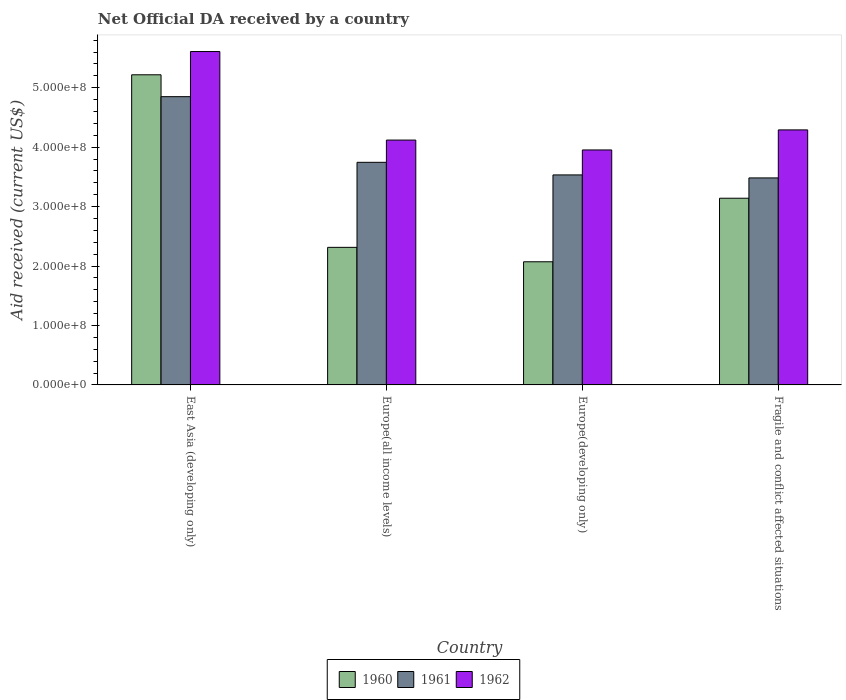How many different coloured bars are there?
Your response must be concise. 3. How many groups of bars are there?
Your answer should be compact. 4. Are the number of bars per tick equal to the number of legend labels?
Your response must be concise. Yes. How many bars are there on the 3rd tick from the right?
Make the answer very short. 3. What is the label of the 3rd group of bars from the left?
Ensure brevity in your answer.  Europe(developing only). What is the net official development assistance aid received in 1960 in Europe(all income levels)?
Make the answer very short. 2.31e+08. Across all countries, what is the maximum net official development assistance aid received in 1960?
Your response must be concise. 5.22e+08. Across all countries, what is the minimum net official development assistance aid received in 1962?
Your response must be concise. 3.95e+08. In which country was the net official development assistance aid received in 1960 maximum?
Your response must be concise. East Asia (developing only). In which country was the net official development assistance aid received in 1961 minimum?
Give a very brief answer. Fragile and conflict affected situations. What is the total net official development assistance aid received in 1960 in the graph?
Your answer should be compact. 1.27e+09. What is the difference between the net official development assistance aid received in 1960 in Europe(all income levels) and that in Fragile and conflict affected situations?
Give a very brief answer. -8.27e+07. What is the difference between the net official development assistance aid received in 1960 in Fragile and conflict affected situations and the net official development assistance aid received in 1961 in Europe(developing only)?
Ensure brevity in your answer.  -3.92e+07. What is the average net official development assistance aid received in 1960 per country?
Offer a terse response. 3.19e+08. What is the difference between the net official development assistance aid received of/in 1962 and net official development assistance aid received of/in 1961 in East Asia (developing only)?
Give a very brief answer. 7.59e+07. In how many countries, is the net official development assistance aid received in 1960 greater than 240000000 US$?
Your answer should be very brief. 2. What is the ratio of the net official development assistance aid received in 1961 in Europe(all income levels) to that in Fragile and conflict affected situations?
Your response must be concise. 1.08. Is the net official development assistance aid received in 1960 in Europe(all income levels) less than that in Fragile and conflict affected situations?
Your response must be concise. Yes. What is the difference between the highest and the second highest net official development assistance aid received in 1962?
Offer a terse response. 1.32e+08. What is the difference between the highest and the lowest net official development assistance aid received in 1962?
Give a very brief answer. 1.66e+08. In how many countries, is the net official development assistance aid received in 1961 greater than the average net official development assistance aid received in 1961 taken over all countries?
Your answer should be very brief. 1. Is the sum of the net official development assistance aid received in 1962 in East Asia (developing only) and Fragile and conflict affected situations greater than the maximum net official development assistance aid received in 1960 across all countries?
Offer a very short reply. Yes. What does the 1st bar from the left in Europe(all income levels) represents?
Give a very brief answer. 1960. Is it the case that in every country, the sum of the net official development assistance aid received in 1961 and net official development assistance aid received in 1960 is greater than the net official development assistance aid received in 1962?
Offer a terse response. Yes. How many bars are there?
Keep it short and to the point. 12. Are all the bars in the graph horizontal?
Your answer should be compact. No. Are the values on the major ticks of Y-axis written in scientific E-notation?
Give a very brief answer. Yes. Does the graph contain any zero values?
Provide a short and direct response. No. Where does the legend appear in the graph?
Your answer should be very brief. Bottom center. What is the title of the graph?
Your answer should be compact. Net Official DA received by a country. What is the label or title of the X-axis?
Your answer should be compact. Country. What is the label or title of the Y-axis?
Offer a terse response. Aid received (current US$). What is the Aid received (current US$) in 1960 in East Asia (developing only)?
Your answer should be very brief. 5.22e+08. What is the Aid received (current US$) in 1961 in East Asia (developing only)?
Your response must be concise. 4.85e+08. What is the Aid received (current US$) of 1962 in East Asia (developing only)?
Your response must be concise. 5.61e+08. What is the Aid received (current US$) of 1960 in Europe(all income levels)?
Ensure brevity in your answer.  2.31e+08. What is the Aid received (current US$) of 1961 in Europe(all income levels)?
Keep it short and to the point. 3.75e+08. What is the Aid received (current US$) of 1962 in Europe(all income levels)?
Offer a very short reply. 4.12e+08. What is the Aid received (current US$) of 1960 in Europe(developing only)?
Provide a short and direct response. 2.07e+08. What is the Aid received (current US$) in 1961 in Europe(developing only)?
Make the answer very short. 3.53e+08. What is the Aid received (current US$) of 1962 in Europe(developing only)?
Give a very brief answer. 3.95e+08. What is the Aid received (current US$) in 1960 in Fragile and conflict affected situations?
Your response must be concise. 3.14e+08. What is the Aid received (current US$) of 1961 in Fragile and conflict affected situations?
Give a very brief answer. 3.48e+08. What is the Aid received (current US$) in 1962 in Fragile and conflict affected situations?
Keep it short and to the point. 4.29e+08. Across all countries, what is the maximum Aid received (current US$) of 1960?
Provide a short and direct response. 5.22e+08. Across all countries, what is the maximum Aid received (current US$) in 1961?
Offer a very short reply. 4.85e+08. Across all countries, what is the maximum Aid received (current US$) in 1962?
Keep it short and to the point. 5.61e+08. Across all countries, what is the minimum Aid received (current US$) in 1960?
Keep it short and to the point. 2.07e+08. Across all countries, what is the minimum Aid received (current US$) of 1961?
Give a very brief answer. 3.48e+08. Across all countries, what is the minimum Aid received (current US$) in 1962?
Make the answer very short. 3.95e+08. What is the total Aid received (current US$) of 1960 in the graph?
Make the answer very short. 1.27e+09. What is the total Aid received (current US$) of 1961 in the graph?
Offer a very short reply. 1.56e+09. What is the total Aid received (current US$) in 1962 in the graph?
Offer a terse response. 1.80e+09. What is the difference between the Aid received (current US$) of 1960 in East Asia (developing only) and that in Europe(all income levels)?
Your response must be concise. 2.90e+08. What is the difference between the Aid received (current US$) of 1961 in East Asia (developing only) and that in Europe(all income levels)?
Ensure brevity in your answer.  1.10e+08. What is the difference between the Aid received (current US$) of 1962 in East Asia (developing only) and that in Europe(all income levels)?
Give a very brief answer. 1.49e+08. What is the difference between the Aid received (current US$) in 1960 in East Asia (developing only) and that in Europe(developing only)?
Offer a terse response. 3.15e+08. What is the difference between the Aid received (current US$) in 1961 in East Asia (developing only) and that in Europe(developing only)?
Your answer should be very brief. 1.32e+08. What is the difference between the Aid received (current US$) in 1962 in East Asia (developing only) and that in Europe(developing only)?
Your response must be concise. 1.66e+08. What is the difference between the Aid received (current US$) of 1960 in East Asia (developing only) and that in Fragile and conflict affected situations?
Ensure brevity in your answer.  2.08e+08. What is the difference between the Aid received (current US$) of 1961 in East Asia (developing only) and that in Fragile and conflict affected situations?
Provide a short and direct response. 1.37e+08. What is the difference between the Aid received (current US$) in 1962 in East Asia (developing only) and that in Fragile and conflict affected situations?
Make the answer very short. 1.32e+08. What is the difference between the Aid received (current US$) of 1960 in Europe(all income levels) and that in Europe(developing only)?
Give a very brief answer. 2.43e+07. What is the difference between the Aid received (current US$) in 1961 in Europe(all income levels) and that in Europe(developing only)?
Your answer should be compact. 2.12e+07. What is the difference between the Aid received (current US$) of 1962 in Europe(all income levels) and that in Europe(developing only)?
Offer a very short reply. 1.66e+07. What is the difference between the Aid received (current US$) of 1960 in Europe(all income levels) and that in Fragile and conflict affected situations?
Your answer should be compact. -8.27e+07. What is the difference between the Aid received (current US$) of 1961 in Europe(all income levels) and that in Fragile and conflict affected situations?
Your answer should be compact. 2.62e+07. What is the difference between the Aid received (current US$) of 1962 in Europe(all income levels) and that in Fragile and conflict affected situations?
Keep it short and to the point. -1.71e+07. What is the difference between the Aid received (current US$) in 1960 in Europe(developing only) and that in Fragile and conflict affected situations?
Provide a succinct answer. -1.07e+08. What is the difference between the Aid received (current US$) in 1961 in Europe(developing only) and that in Fragile and conflict affected situations?
Ensure brevity in your answer.  5.04e+06. What is the difference between the Aid received (current US$) in 1962 in Europe(developing only) and that in Fragile and conflict affected situations?
Your answer should be compact. -3.38e+07. What is the difference between the Aid received (current US$) in 1960 in East Asia (developing only) and the Aid received (current US$) in 1961 in Europe(all income levels)?
Provide a short and direct response. 1.47e+08. What is the difference between the Aid received (current US$) of 1960 in East Asia (developing only) and the Aid received (current US$) of 1962 in Europe(all income levels)?
Your answer should be compact. 1.10e+08. What is the difference between the Aid received (current US$) in 1961 in East Asia (developing only) and the Aid received (current US$) in 1962 in Europe(all income levels)?
Give a very brief answer. 7.30e+07. What is the difference between the Aid received (current US$) in 1960 in East Asia (developing only) and the Aid received (current US$) in 1961 in Europe(developing only)?
Offer a terse response. 1.68e+08. What is the difference between the Aid received (current US$) in 1960 in East Asia (developing only) and the Aid received (current US$) in 1962 in Europe(developing only)?
Keep it short and to the point. 1.26e+08. What is the difference between the Aid received (current US$) in 1961 in East Asia (developing only) and the Aid received (current US$) in 1962 in Europe(developing only)?
Your response must be concise. 8.97e+07. What is the difference between the Aid received (current US$) in 1960 in East Asia (developing only) and the Aid received (current US$) in 1961 in Fragile and conflict affected situations?
Give a very brief answer. 1.74e+08. What is the difference between the Aid received (current US$) in 1960 in East Asia (developing only) and the Aid received (current US$) in 1962 in Fragile and conflict affected situations?
Offer a terse response. 9.27e+07. What is the difference between the Aid received (current US$) of 1961 in East Asia (developing only) and the Aid received (current US$) of 1962 in Fragile and conflict affected situations?
Offer a very short reply. 5.59e+07. What is the difference between the Aid received (current US$) of 1960 in Europe(all income levels) and the Aid received (current US$) of 1961 in Europe(developing only)?
Make the answer very short. -1.22e+08. What is the difference between the Aid received (current US$) in 1960 in Europe(all income levels) and the Aid received (current US$) in 1962 in Europe(developing only)?
Your response must be concise. -1.64e+08. What is the difference between the Aid received (current US$) of 1961 in Europe(all income levels) and the Aid received (current US$) of 1962 in Europe(developing only)?
Your answer should be compact. -2.08e+07. What is the difference between the Aid received (current US$) in 1960 in Europe(all income levels) and the Aid received (current US$) in 1961 in Fragile and conflict affected situations?
Give a very brief answer. -1.17e+08. What is the difference between the Aid received (current US$) in 1960 in Europe(all income levels) and the Aid received (current US$) in 1962 in Fragile and conflict affected situations?
Offer a very short reply. -1.98e+08. What is the difference between the Aid received (current US$) in 1961 in Europe(all income levels) and the Aid received (current US$) in 1962 in Fragile and conflict affected situations?
Give a very brief answer. -5.46e+07. What is the difference between the Aid received (current US$) in 1960 in Europe(developing only) and the Aid received (current US$) in 1961 in Fragile and conflict affected situations?
Make the answer very short. -1.41e+08. What is the difference between the Aid received (current US$) in 1960 in Europe(developing only) and the Aid received (current US$) in 1962 in Fragile and conflict affected situations?
Your answer should be very brief. -2.22e+08. What is the difference between the Aid received (current US$) in 1961 in Europe(developing only) and the Aid received (current US$) in 1962 in Fragile and conflict affected situations?
Ensure brevity in your answer.  -7.58e+07. What is the average Aid received (current US$) of 1960 per country?
Your response must be concise. 3.19e+08. What is the average Aid received (current US$) of 1961 per country?
Your answer should be compact. 3.90e+08. What is the average Aid received (current US$) of 1962 per country?
Ensure brevity in your answer.  4.49e+08. What is the difference between the Aid received (current US$) of 1960 and Aid received (current US$) of 1961 in East Asia (developing only)?
Your answer should be compact. 3.68e+07. What is the difference between the Aid received (current US$) of 1960 and Aid received (current US$) of 1962 in East Asia (developing only)?
Your answer should be compact. -3.91e+07. What is the difference between the Aid received (current US$) in 1961 and Aid received (current US$) in 1962 in East Asia (developing only)?
Ensure brevity in your answer.  -7.59e+07. What is the difference between the Aid received (current US$) of 1960 and Aid received (current US$) of 1961 in Europe(all income levels)?
Keep it short and to the point. -1.43e+08. What is the difference between the Aid received (current US$) in 1960 and Aid received (current US$) in 1962 in Europe(all income levels)?
Keep it short and to the point. -1.81e+08. What is the difference between the Aid received (current US$) in 1961 and Aid received (current US$) in 1962 in Europe(all income levels)?
Your answer should be compact. -3.74e+07. What is the difference between the Aid received (current US$) in 1960 and Aid received (current US$) in 1961 in Europe(developing only)?
Provide a short and direct response. -1.46e+08. What is the difference between the Aid received (current US$) in 1960 and Aid received (current US$) in 1962 in Europe(developing only)?
Make the answer very short. -1.88e+08. What is the difference between the Aid received (current US$) of 1961 and Aid received (current US$) of 1962 in Europe(developing only)?
Keep it short and to the point. -4.20e+07. What is the difference between the Aid received (current US$) in 1960 and Aid received (current US$) in 1961 in Fragile and conflict affected situations?
Offer a very short reply. -3.42e+07. What is the difference between the Aid received (current US$) in 1960 and Aid received (current US$) in 1962 in Fragile and conflict affected situations?
Provide a short and direct response. -1.15e+08. What is the difference between the Aid received (current US$) in 1961 and Aid received (current US$) in 1962 in Fragile and conflict affected situations?
Offer a very short reply. -8.08e+07. What is the ratio of the Aid received (current US$) in 1960 in East Asia (developing only) to that in Europe(all income levels)?
Make the answer very short. 2.25. What is the ratio of the Aid received (current US$) in 1961 in East Asia (developing only) to that in Europe(all income levels)?
Offer a very short reply. 1.29. What is the ratio of the Aid received (current US$) of 1962 in East Asia (developing only) to that in Europe(all income levels)?
Offer a terse response. 1.36. What is the ratio of the Aid received (current US$) in 1960 in East Asia (developing only) to that in Europe(developing only)?
Provide a short and direct response. 2.52. What is the ratio of the Aid received (current US$) of 1961 in East Asia (developing only) to that in Europe(developing only)?
Your answer should be very brief. 1.37. What is the ratio of the Aid received (current US$) in 1962 in East Asia (developing only) to that in Europe(developing only)?
Give a very brief answer. 1.42. What is the ratio of the Aid received (current US$) in 1960 in East Asia (developing only) to that in Fragile and conflict affected situations?
Offer a very short reply. 1.66. What is the ratio of the Aid received (current US$) in 1961 in East Asia (developing only) to that in Fragile and conflict affected situations?
Your answer should be very brief. 1.39. What is the ratio of the Aid received (current US$) of 1962 in East Asia (developing only) to that in Fragile and conflict affected situations?
Your answer should be compact. 1.31. What is the ratio of the Aid received (current US$) in 1960 in Europe(all income levels) to that in Europe(developing only)?
Your answer should be very brief. 1.12. What is the ratio of the Aid received (current US$) in 1961 in Europe(all income levels) to that in Europe(developing only)?
Ensure brevity in your answer.  1.06. What is the ratio of the Aid received (current US$) in 1962 in Europe(all income levels) to that in Europe(developing only)?
Offer a very short reply. 1.04. What is the ratio of the Aid received (current US$) in 1960 in Europe(all income levels) to that in Fragile and conflict affected situations?
Ensure brevity in your answer.  0.74. What is the ratio of the Aid received (current US$) of 1961 in Europe(all income levels) to that in Fragile and conflict affected situations?
Your answer should be very brief. 1.08. What is the ratio of the Aid received (current US$) in 1962 in Europe(all income levels) to that in Fragile and conflict affected situations?
Your response must be concise. 0.96. What is the ratio of the Aid received (current US$) of 1960 in Europe(developing only) to that in Fragile and conflict affected situations?
Provide a short and direct response. 0.66. What is the ratio of the Aid received (current US$) of 1961 in Europe(developing only) to that in Fragile and conflict affected situations?
Your answer should be very brief. 1.01. What is the ratio of the Aid received (current US$) of 1962 in Europe(developing only) to that in Fragile and conflict affected situations?
Your response must be concise. 0.92. What is the difference between the highest and the second highest Aid received (current US$) of 1960?
Provide a short and direct response. 2.08e+08. What is the difference between the highest and the second highest Aid received (current US$) in 1961?
Keep it short and to the point. 1.10e+08. What is the difference between the highest and the second highest Aid received (current US$) of 1962?
Your answer should be very brief. 1.32e+08. What is the difference between the highest and the lowest Aid received (current US$) in 1960?
Provide a short and direct response. 3.15e+08. What is the difference between the highest and the lowest Aid received (current US$) of 1961?
Offer a terse response. 1.37e+08. What is the difference between the highest and the lowest Aid received (current US$) in 1962?
Your answer should be very brief. 1.66e+08. 